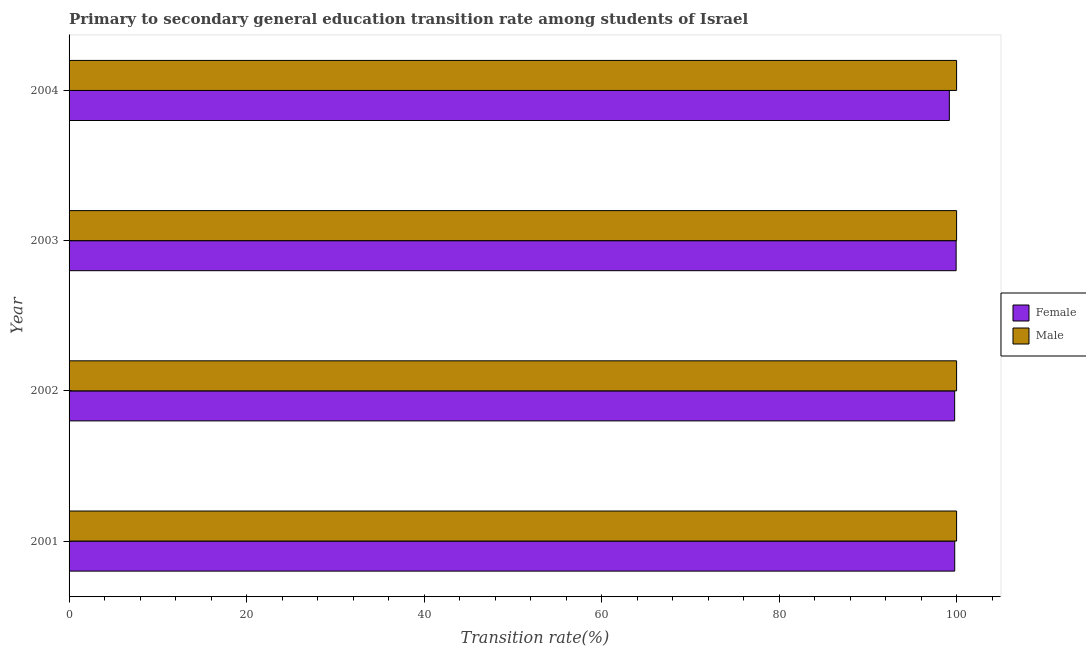How many different coloured bars are there?
Your answer should be very brief. 2. How many groups of bars are there?
Provide a succinct answer. 4. Are the number of bars per tick equal to the number of legend labels?
Your response must be concise. Yes. How many bars are there on the 2nd tick from the top?
Ensure brevity in your answer.  2. What is the transition rate among female students in 2004?
Keep it short and to the point. 99.18. Across all years, what is the maximum transition rate among male students?
Offer a very short reply. 100. In which year was the transition rate among male students maximum?
Your answer should be very brief. 2001. In which year was the transition rate among female students minimum?
Provide a short and direct response. 2004. What is the total transition rate among female students in the graph?
Offer a very short reply. 398.7. What is the difference between the transition rate among female students in 2001 and that in 2004?
Your answer should be compact. 0.61. What is the difference between the transition rate among male students in 2003 and the transition rate among female students in 2004?
Keep it short and to the point. 0.82. What is the average transition rate among male students per year?
Your answer should be compact. 100. In the year 2001, what is the difference between the transition rate among male students and transition rate among female students?
Provide a short and direct response. 0.21. What is the ratio of the transition rate among male students in 2001 to that in 2002?
Provide a short and direct response. 1. Is the transition rate among male students in 2001 less than that in 2002?
Keep it short and to the point. No. What is the difference between the highest and the second highest transition rate among female students?
Provide a succinct answer. 0.16. What is the difference between the highest and the lowest transition rate among female students?
Provide a short and direct response. 0.76. In how many years, is the transition rate among female students greater than the average transition rate among female students taken over all years?
Keep it short and to the point. 3. What does the 1st bar from the bottom in 2001 represents?
Keep it short and to the point. Female. What is the difference between two consecutive major ticks on the X-axis?
Offer a terse response. 20. Does the graph contain any zero values?
Offer a very short reply. No. Where does the legend appear in the graph?
Provide a succinct answer. Center right. What is the title of the graph?
Your answer should be compact. Primary to secondary general education transition rate among students of Israel. Does "Depositors" appear as one of the legend labels in the graph?
Give a very brief answer. No. What is the label or title of the X-axis?
Your answer should be very brief. Transition rate(%). What is the Transition rate(%) in Female in 2001?
Make the answer very short. 99.79. What is the Transition rate(%) of Female in 2002?
Provide a short and direct response. 99.78. What is the Transition rate(%) in Male in 2002?
Keep it short and to the point. 100. What is the Transition rate(%) of Female in 2003?
Your answer should be very brief. 99.95. What is the Transition rate(%) in Female in 2004?
Your answer should be compact. 99.18. Across all years, what is the maximum Transition rate(%) of Female?
Give a very brief answer. 99.95. Across all years, what is the minimum Transition rate(%) of Female?
Your answer should be very brief. 99.18. What is the total Transition rate(%) in Female in the graph?
Ensure brevity in your answer.  398.7. What is the total Transition rate(%) in Male in the graph?
Keep it short and to the point. 400. What is the difference between the Transition rate(%) in Female in 2001 and that in 2002?
Ensure brevity in your answer.  0.01. What is the difference between the Transition rate(%) of Female in 2001 and that in 2003?
Your answer should be very brief. -0.16. What is the difference between the Transition rate(%) in Female in 2001 and that in 2004?
Provide a succinct answer. 0.61. What is the difference between the Transition rate(%) of Male in 2001 and that in 2004?
Make the answer very short. 0. What is the difference between the Transition rate(%) in Female in 2002 and that in 2003?
Your answer should be compact. -0.17. What is the difference between the Transition rate(%) in Female in 2002 and that in 2004?
Make the answer very short. 0.6. What is the difference between the Transition rate(%) of Female in 2003 and that in 2004?
Provide a short and direct response. 0.76. What is the difference between the Transition rate(%) in Male in 2003 and that in 2004?
Provide a short and direct response. 0. What is the difference between the Transition rate(%) in Female in 2001 and the Transition rate(%) in Male in 2002?
Give a very brief answer. -0.21. What is the difference between the Transition rate(%) in Female in 2001 and the Transition rate(%) in Male in 2003?
Offer a very short reply. -0.21. What is the difference between the Transition rate(%) of Female in 2001 and the Transition rate(%) of Male in 2004?
Provide a short and direct response. -0.21. What is the difference between the Transition rate(%) of Female in 2002 and the Transition rate(%) of Male in 2003?
Provide a succinct answer. -0.22. What is the difference between the Transition rate(%) in Female in 2002 and the Transition rate(%) in Male in 2004?
Give a very brief answer. -0.22. What is the difference between the Transition rate(%) in Female in 2003 and the Transition rate(%) in Male in 2004?
Your answer should be very brief. -0.05. What is the average Transition rate(%) of Female per year?
Offer a very short reply. 99.67. In the year 2001, what is the difference between the Transition rate(%) in Female and Transition rate(%) in Male?
Ensure brevity in your answer.  -0.21. In the year 2002, what is the difference between the Transition rate(%) of Female and Transition rate(%) of Male?
Your response must be concise. -0.22. In the year 2003, what is the difference between the Transition rate(%) of Female and Transition rate(%) of Male?
Give a very brief answer. -0.05. In the year 2004, what is the difference between the Transition rate(%) in Female and Transition rate(%) in Male?
Ensure brevity in your answer.  -0.82. What is the ratio of the Transition rate(%) of Male in 2001 to that in 2002?
Provide a short and direct response. 1. What is the ratio of the Transition rate(%) of Female in 2001 to that in 2003?
Provide a succinct answer. 1. What is the ratio of the Transition rate(%) of Male in 2001 to that in 2003?
Offer a terse response. 1. What is the ratio of the Transition rate(%) of Male in 2001 to that in 2004?
Provide a short and direct response. 1. What is the ratio of the Transition rate(%) of Male in 2002 to that in 2003?
Your answer should be very brief. 1. What is the ratio of the Transition rate(%) of Male in 2002 to that in 2004?
Give a very brief answer. 1. What is the ratio of the Transition rate(%) of Female in 2003 to that in 2004?
Offer a very short reply. 1.01. What is the ratio of the Transition rate(%) of Male in 2003 to that in 2004?
Your answer should be compact. 1. What is the difference between the highest and the second highest Transition rate(%) in Female?
Provide a succinct answer. 0.16. What is the difference between the highest and the second highest Transition rate(%) of Male?
Your answer should be very brief. 0. What is the difference between the highest and the lowest Transition rate(%) of Female?
Your answer should be compact. 0.76. What is the difference between the highest and the lowest Transition rate(%) of Male?
Provide a succinct answer. 0. 